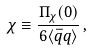<formula> <loc_0><loc_0><loc_500><loc_500>\chi \equiv \frac { \Pi _ { \chi } ( 0 ) } { 6 \langle \bar { q } q \rangle } \, ,</formula> 